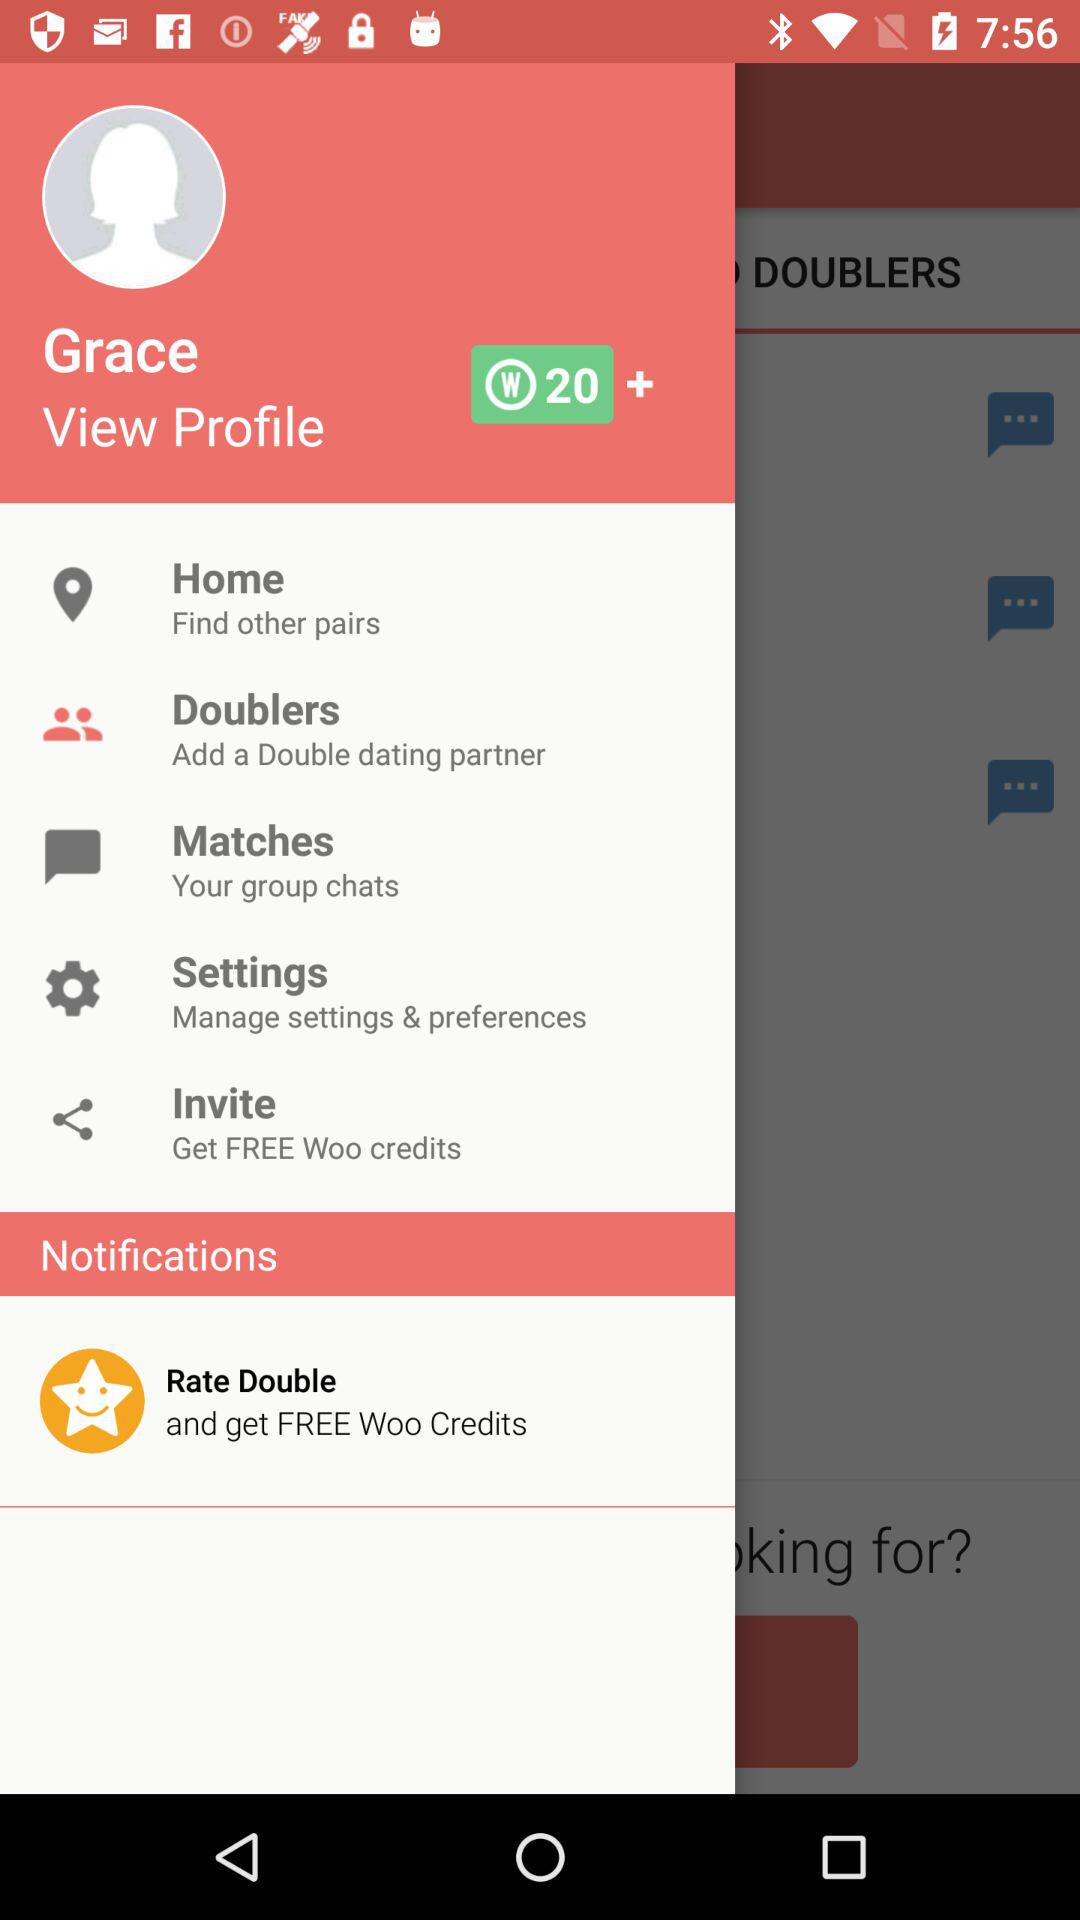What is the username? The username is Grace. 